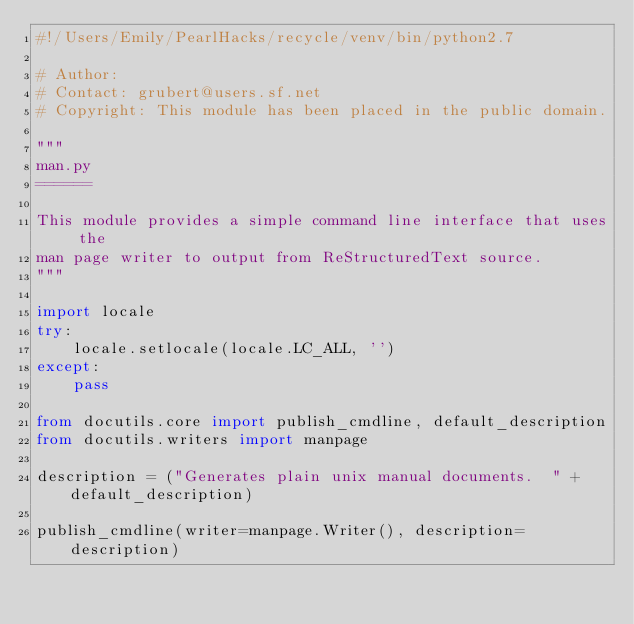<code> <loc_0><loc_0><loc_500><loc_500><_Python_>#!/Users/Emily/PearlHacks/recycle/venv/bin/python2.7

# Author: 
# Contact: grubert@users.sf.net
# Copyright: This module has been placed in the public domain.

"""
man.py
======

This module provides a simple command line interface that uses the
man page writer to output from ReStructuredText source.
"""

import locale
try:
    locale.setlocale(locale.LC_ALL, '')
except:
    pass

from docutils.core import publish_cmdline, default_description
from docutils.writers import manpage

description = ("Generates plain unix manual documents.  " + default_description)

publish_cmdline(writer=manpage.Writer(), description=description)
</code> 